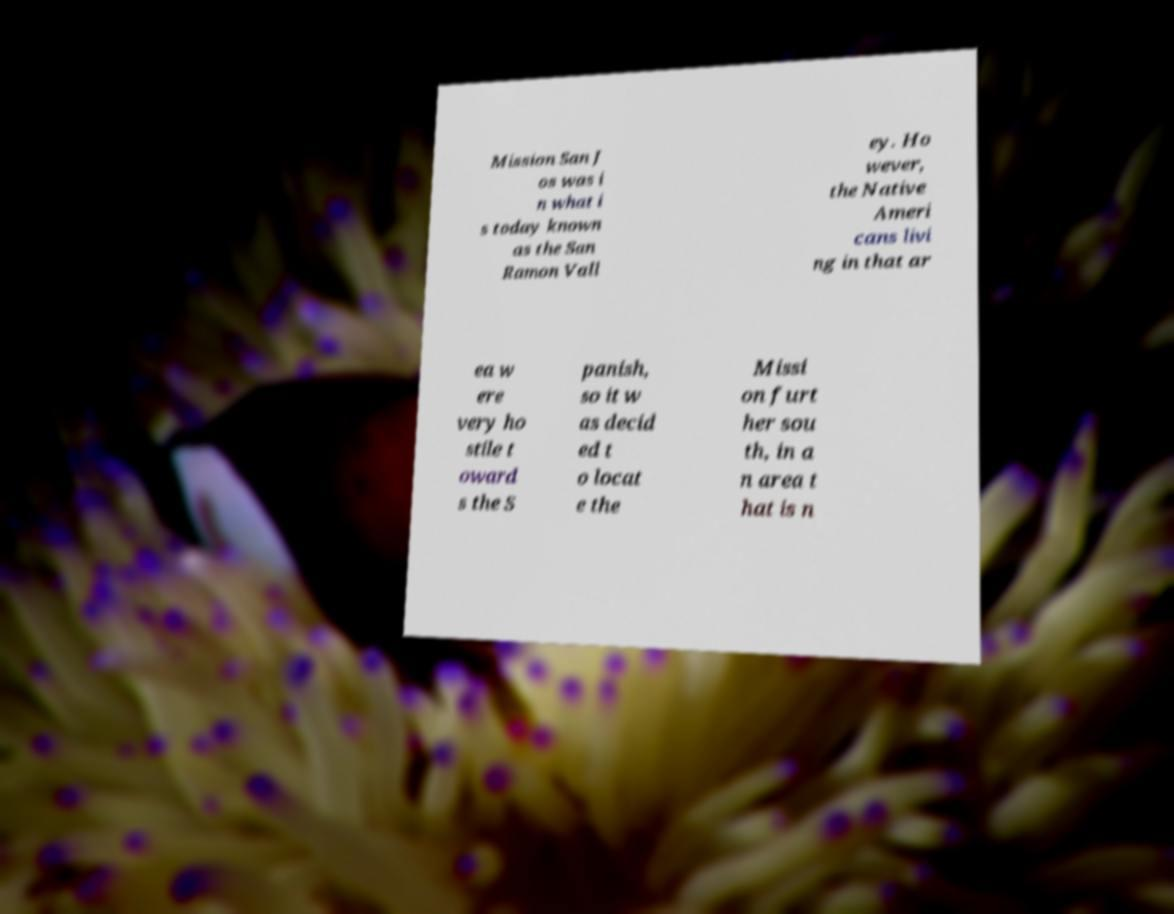Please identify and transcribe the text found in this image. Mission San J os was i n what i s today known as the San Ramon Vall ey. Ho wever, the Native Ameri cans livi ng in that ar ea w ere very ho stile t oward s the S panish, so it w as decid ed t o locat e the Missi on furt her sou th, in a n area t hat is n 